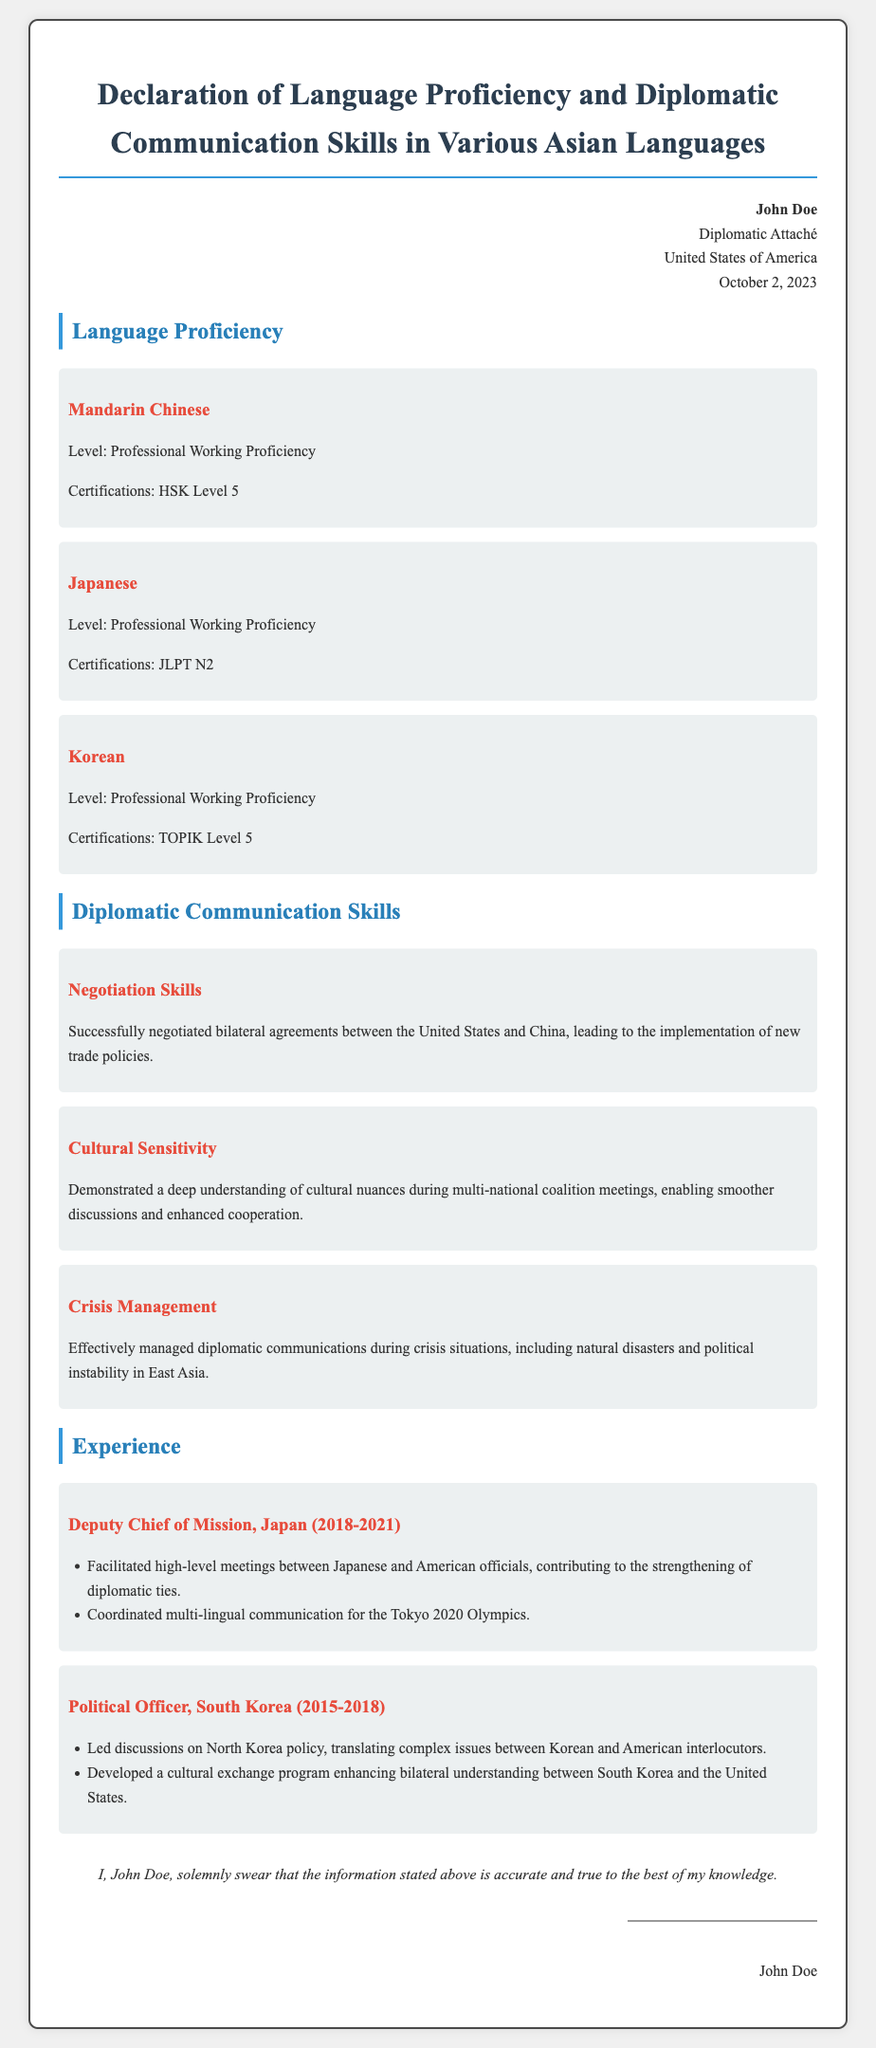What is the profession of the individual in the document? The document indicates that the individual is a Diplomatic Attaché.
Answer: Diplomatic Attaché What languages does John Doe demonstrate proficiency in? The document lists three languages: Mandarin Chinese, Japanese, and Korean.
Answer: Mandarin Chinese, Japanese, Korean What is the highest proficiency level John Doe has achieved in Mandarin Chinese? According to the document, the proficiency level for Mandarin Chinese is Professional Working Proficiency.
Answer: Professional Working Proficiency In which country did John Doe serve as Deputy Chief of Mission? The document states that he served in Japan from 2018 to 2021.
Answer: Japan What specific certification does John Doe hold for his Japanese language proficiency? The document lists JLPT N2 as the certification for Japanese language proficiency.
Answer: JLPT N2 What skill involves managing communications during crisis situations? The document refers to this skill as Crisis Management.
Answer: Crisis Management How long did John Doe work as a Political Officer in South Korea? The document indicates that he worked there from 2015 to 2018, which is a period of 3 years.
Answer: 3 years What was one of John Doe's responsibilities during the Tokyo 2020 Olympics? He coordinated multi-lingual communication for the event.
Answer: Coordinated multi-lingual communication What does John Doe affirm about the accuracy of the information in the document? He solemnly swears that the stated information is accurate and true to the best of his knowledge.
Answer: Accurate and true 